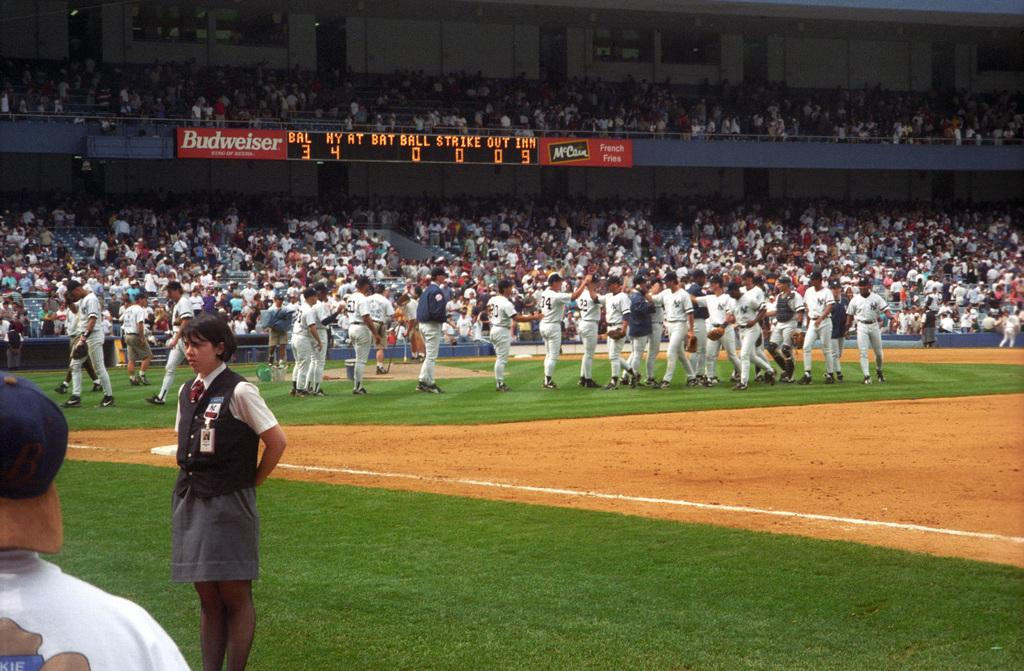<image>
Give a short and clear explanation of the subsequent image. Baseball players on a field with the ad for BUdweiser by the scoreboard.' 